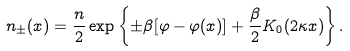<formula> <loc_0><loc_0><loc_500><loc_500>n _ { \pm } ( x ) = \frac { n } { 2 } \exp \left \{ \pm \beta [ \varphi - \varphi ( x ) ] + \frac { \beta } { 2 } K _ { 0 } ( 2 \kappa x ) \right \} .</formula> 